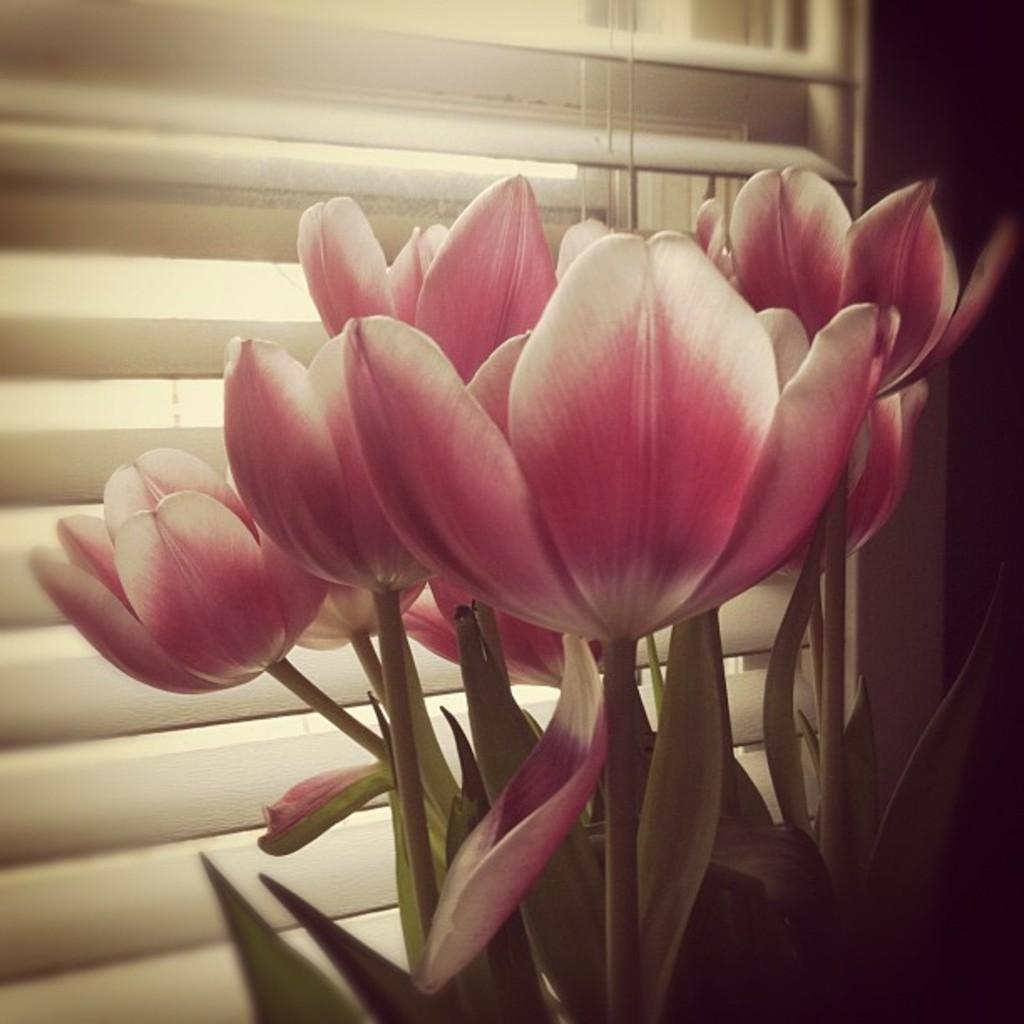What type of plants can be seen in the image? There are flowers in the image. What colors are the flowers? The flowers are pink and white in color. What else is visible in the image besides the flowers? There are leaves and a stem visible in the image. What can be seen in the background of the image? There is a window and window blinds visible in the image. Can you tell me how many snakes are slithering around the flowers in the image? There are no snakes present in the image; it features flowers, leaves, and stems. What type of mask is being worn by the person holding the flowers in the image? There is no person or mask present in the image; it only features flowers, leaves, and stems. 